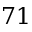<formula> <loc_0><loc_0><loc_500><loc_500>7 1</formula> 